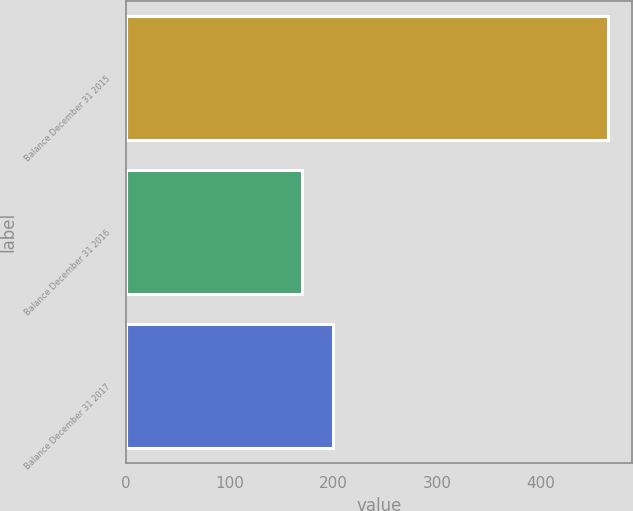Convert chart. <chart><loc_0><loc_0><loc_500><loc_500><bar_chart><fcel>Balance December 31 2015<fcel>Balance December 31 2016<fcel>Balance December 31 2017<nl><fcel>464<fcel>170<fcel>199.4<nl></chart> 